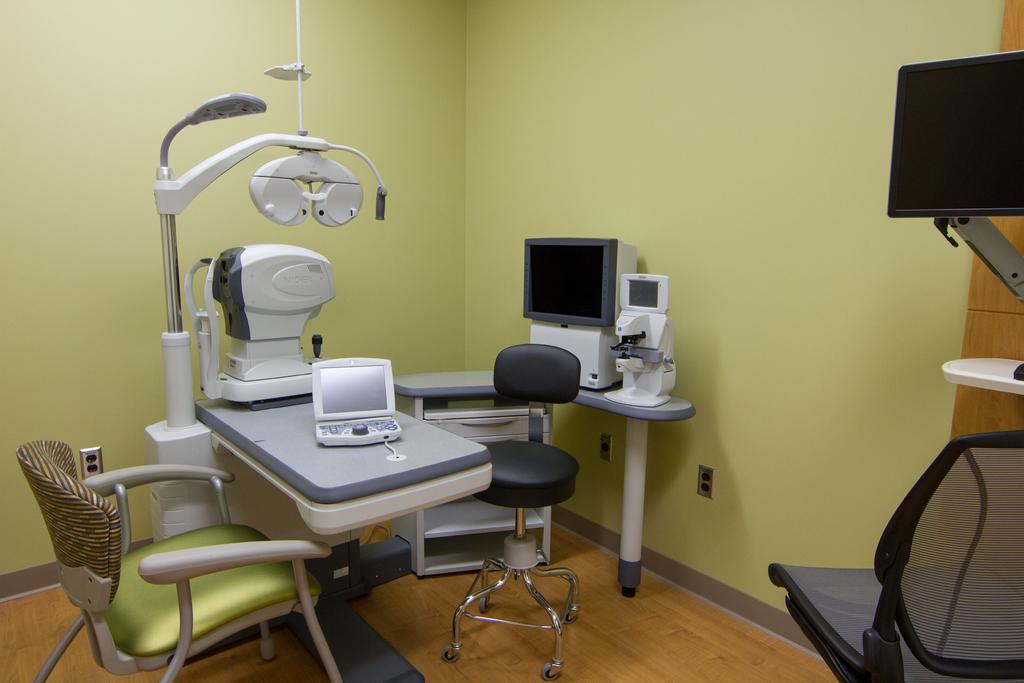What type of space is depicted in the image? The image shows an inner view of a room. What electronic devices are present in the room? There are computers in the room. What furniture is available for seating in the room? There are chairs in the room. What additional furniture is present in the room? There are side tables in the room. What other equipment can be found in the room? There are machines in the room. What surrounds the room in the image? The background of the image includes walls. How many cushions are visible on the chairs in the image? There is no mention of cushions on the chairs in the image; only chairs are mentioned. What type of bead is used to decorate the walls in the image? There is no mention of beads or any decorative elements on the walls in the image; only walls are mentioned. 